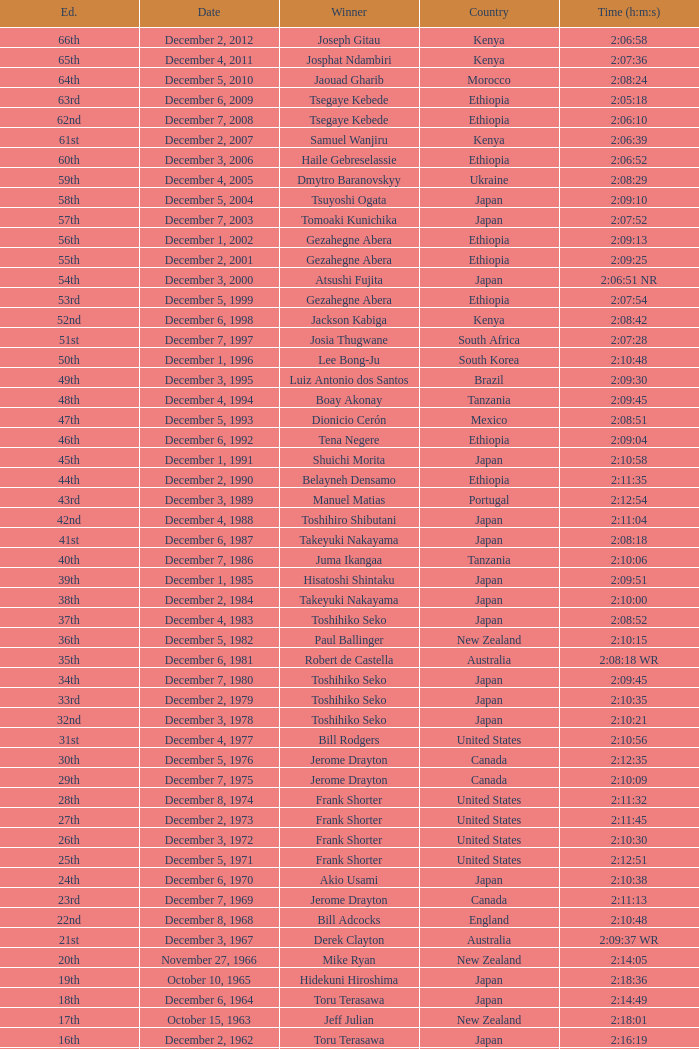What was the nationality of the winner of the 42nd Edition? Japan. 